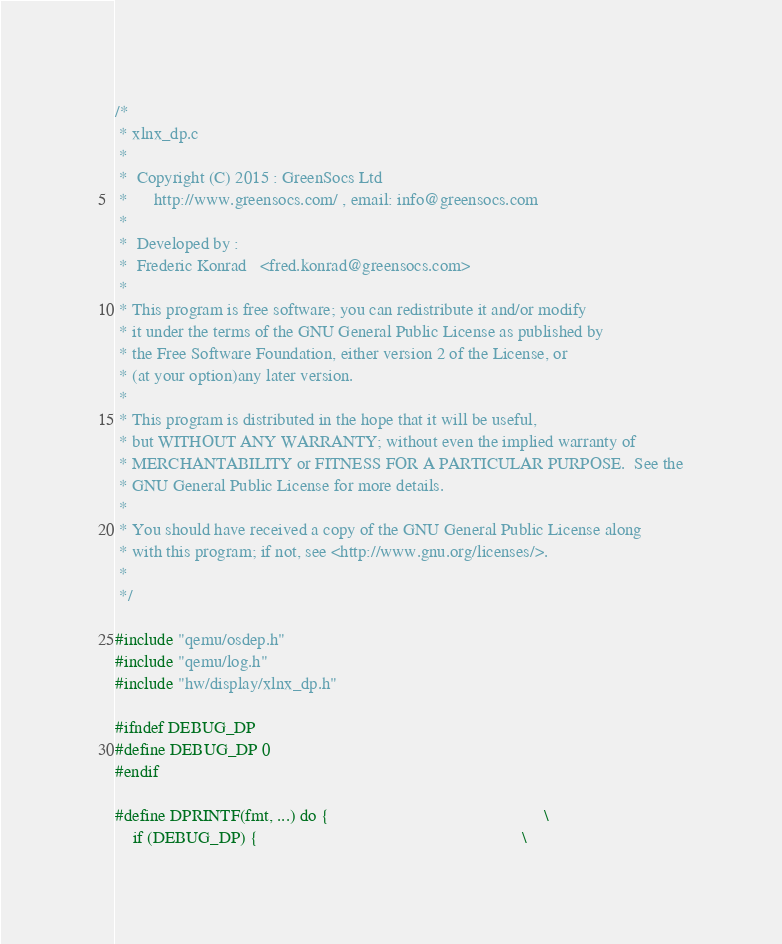Convert code to text. <code><loc_0><loc_0><loc_500><loc_500><_C_>/*
 * xlnx_dp.c
 *
 *  Copyright (C) 2015 : GreenSocs Ltd
 *      http://www.greensocs.com/ , email: info@greensocs.com
 *
 *  Developed by :
 *  Frederic Konrad   <fred.konrad@greensocs.com>
 *
 * This program is free software; you can redistribute it and/or modify
 * it under the terms of the GNU General Public License as published by
 * the Free Software Foundation, either version 2 of the License, or
 * (at your option)any later version.
 *
 * This program is distributed in the hope that it will be useful,
 * but WITHOUT ANY WARRANTY; without even the implied warranty of
 * MERCHANTABILITY or FITNESS FOR A PARTICULAR PURPOSE.  See the
 * GNU General Public License for more details.
 *
 * You should have received a copy of the GNU General Public License along
 * with this program; if not, see <http://www.gnu.org/licenses/>.
 *
 */

#include "qemu/osdep.h"
#include "qemu/log.h"
#include "hw/display/xlnx_dp.h"

#ifndef DEBUG_DP
#define DEBUG_DP 0
#endif

#define DPRINTF(fmt, ...) do {                                                 \
    if (DEBUG_DP) {                                                            \</code> 